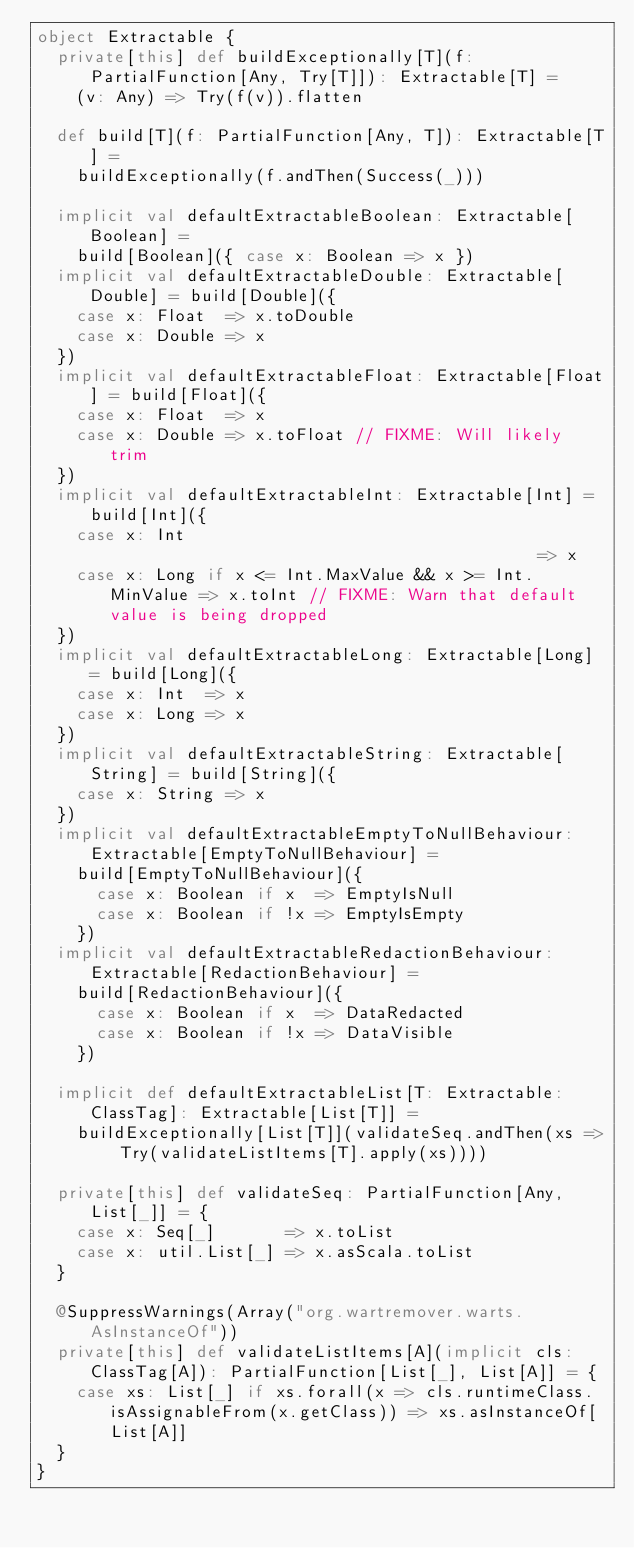Convert code to text. <code><loc_0><loc_0><loc_500><loc_500><_Scala_>object Extractable {
  private[this] def buildExceptionally[T](f: PartialFunction[Any, Try[T]]): Extractable[T] =
    (v: Any) => Try(f(v)).flatten

  def build[T](f: PartialFunction[Any, T]): Extractable[T] =
    buildExceptionally(f.andThen(Success(_)))

  implicit val defaultExtractableBoolean: Extractable[Boolean] =
    build[Boolean]({ case x: Boolean => x })
  implicit val defaultExtractableDouble: Extractable[Double] = build[Double]({
    case x: Float  => x.toDouble
    case x: Double => x
  })
  implicit val defaultExtractableFloat: Extractable[Float] = build[Float]({
    case x: Float  => x
    case x: Double => x.toFloat // FIXME: Will likely trim
  })
  implicit val defaultExtractableInt: Extractable[Int] = build[Int]({
    case x: Int                                            => x
    case x: Long if x <= Int.MaxValue && x >= Int.MinValue => x.toInt // FIXME: Warn that default value is being dropped
  })
  implicit val defaultExtractableLong: Extractable[Long] = build[Long]({
    case x: Int  => x
    case x: Long => x
  })
  implicit val defaultExtractableString: Extractable[String] = build[String]({
    case x: String => x
  })
  implicit val defaultExtractableEmptyToNullBehaviour: Extractable[EmptyToNullBehaviour] =
    build[EmptyToNullBehaviour]({
      case x: Boolean if x  => EmptyIsNull
      case x: Boolean if !x => EmptyIsEmpty
    })
  implicit val defaultExtractableRedactionBehaviour: Extractable[RedactionBehaviour] =
    build[RedactionBehaviour]({
      case x: Boolean if x  => DataRedacted
      case x: Boolean if !x => DataVisible
    })

  implicit def defaultExtractableList[T: Extractable: ClassTag]: Extractable[List[T]] =
    buildExceptionally[List[T]](validateSeq.andThen(xs => Try(validateListItems[T].apply(xs))))

  private[this] def validateSeq: PartialFunction[Any, List[_]] = {
    case x: Seq[_]       => x.toList
    case x: util.List[_] => x.asScala.toList
  }

  @SuppressWarnings(Array("org.wartremover.warts.AsInstanceOf"))
  private[this] def validateListItems[A](implicit cls: ClassTag[A]): PartialFunction[List[_], List[A]] = {
    case xs: List[_] if xs.forall(x => cls.runtimeClass.isAssignableFrom(x.getClass)) => xs.asInstanceOf[List[A]]
  }
}
</code> 